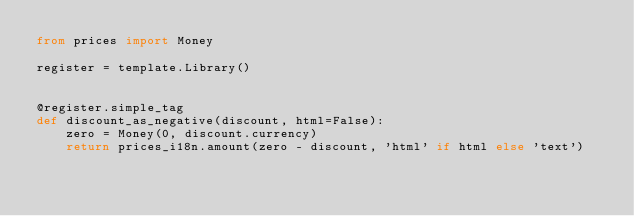Convert code to text. <code><loc_0><loc_0><loc_500><loc_500><_Python_>from prices import Money

register = template.Library()


@register.simple_tag
def discount_as_negative(discount, html=False):
    zero = Money(0, discount.currency)
    return prices_i18n.amount(zero - discount, 'html' if html else 'text')
</code> 